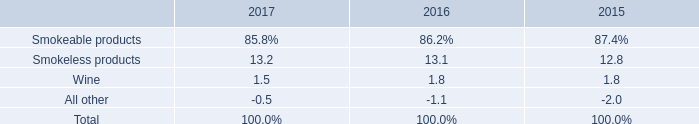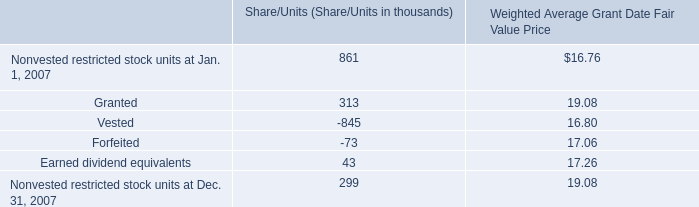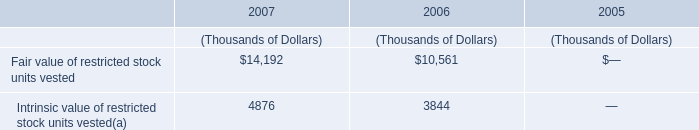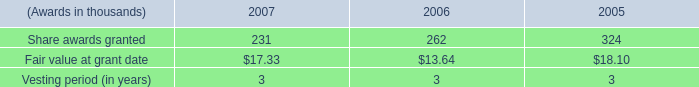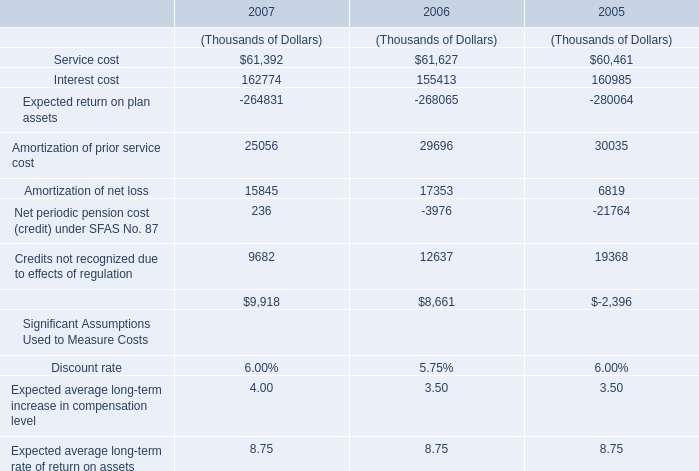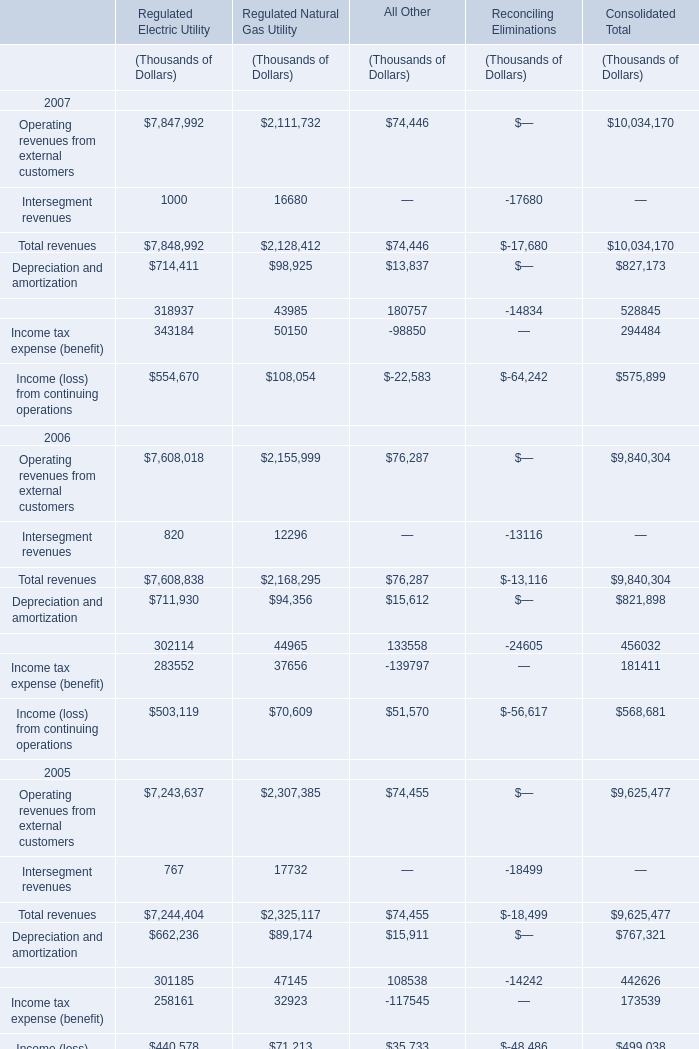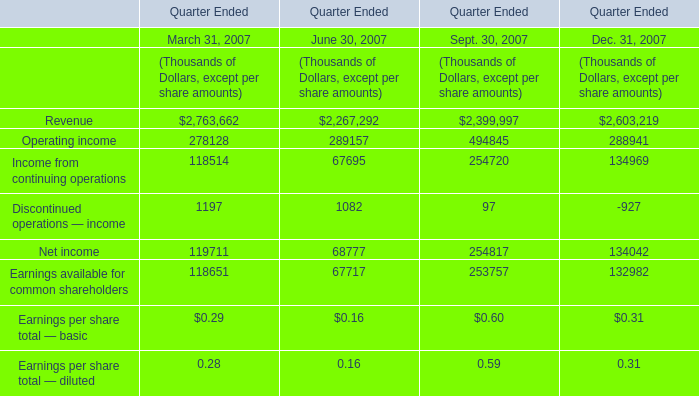What's the 10 % of total elements for Sept. 30, 2007 in 2007? (in Thousand) 
Computations: ((((((2399997 + 494845) + 254720) + 97) + 254817) + 253757) * 0.1)
Answer: 365823.3. 